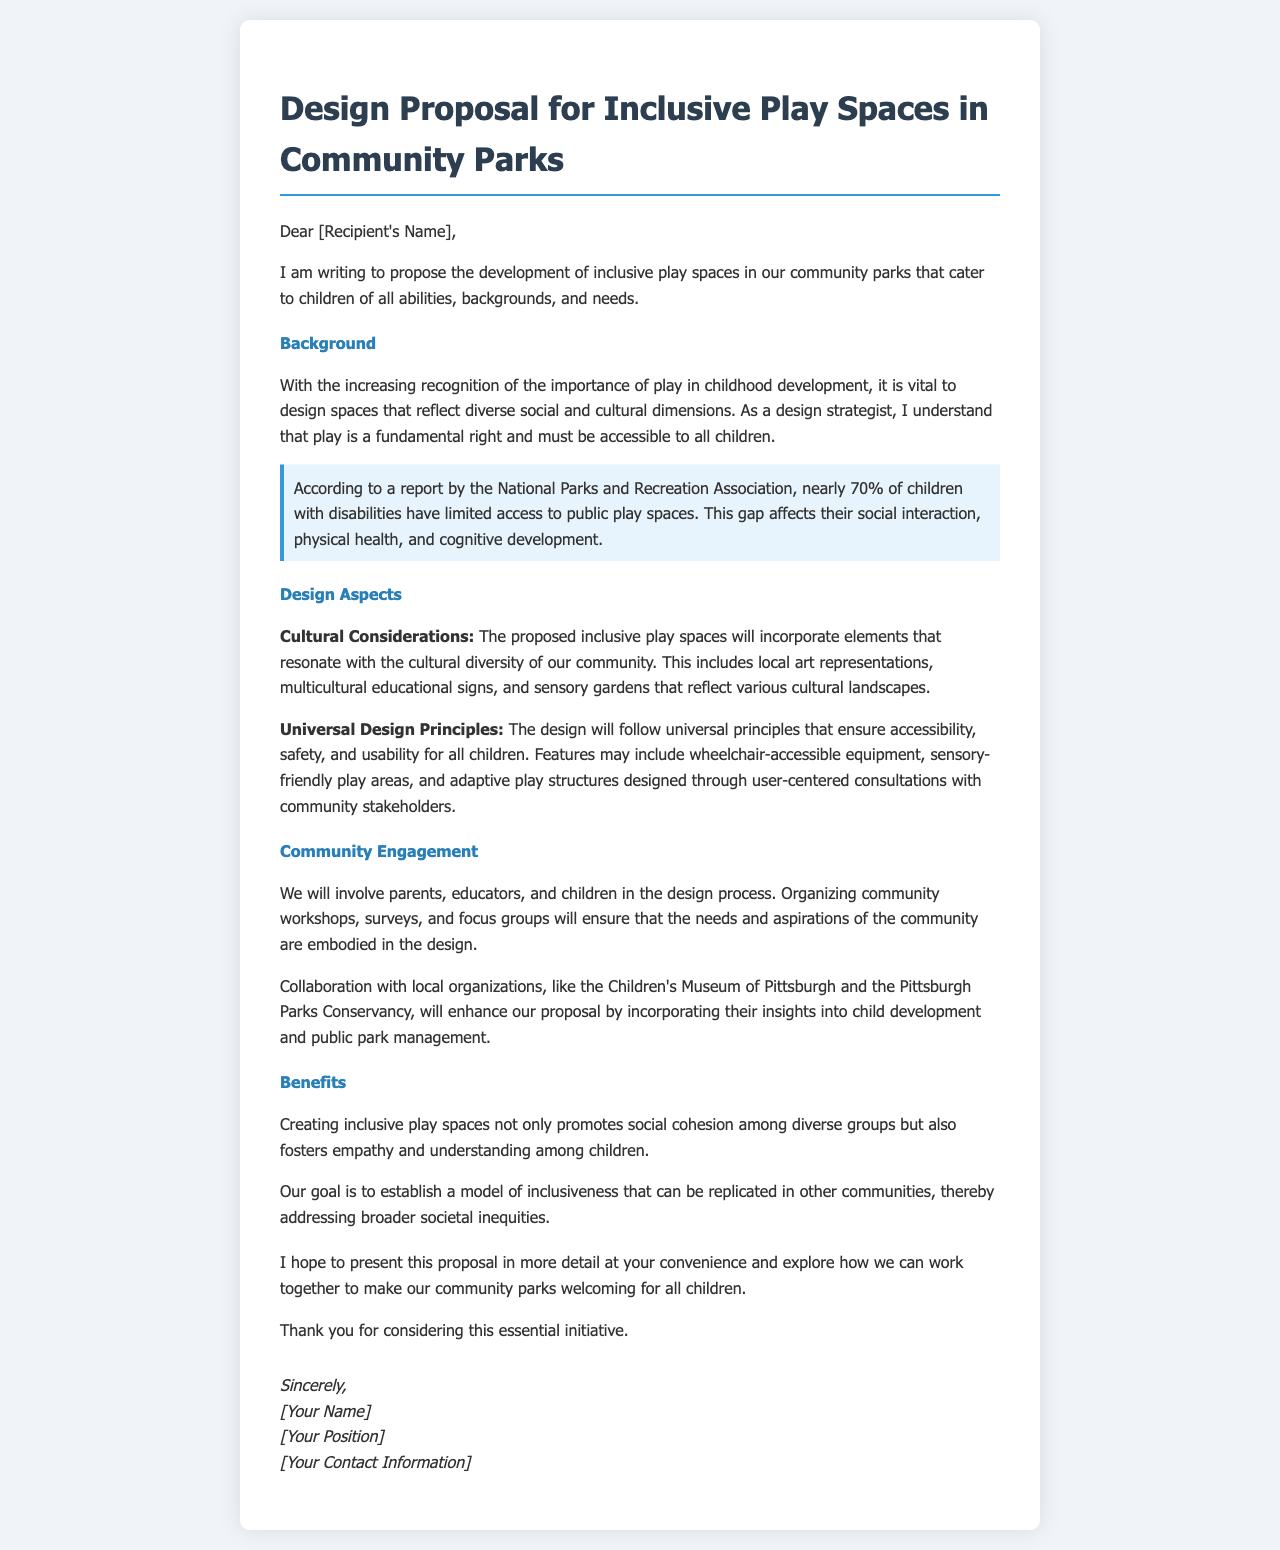what is the main proposal in the letter? The letter proposes the development of inclusive play spaces in community parks for children of all abilities, backgrounds, and needs.
Answer: inclusive play spaces how many percent of children with disabilities have limited access to public play spaces? The document states that nearly 70% of children with disabilities have limited access to public play spaces.
Answer: 70% what type of organizations will be collaborated with? The proposal mentions collaboration with local organizations like the Children's Museum of Pittsburgh and the Pittsburgh Parks Conservancy.
Answer: Children's Museum of Pittsburgh and the Pittsburgh Parks Conservancy what are the cultural aspects included in the design? The design will incorporate elements like local art representations, multicultural educational signs, and sensory gardens reflecting various cultural landscapes.
Answer: local art representations, multicultural educational signs, sensory gardens who will be involved in the design process? Parents, educators, and children will be involved in the design process through workshops, surveys, and focus groups.
Answer: Parents, educators, and children what principle will the design follow? The design will follow universal principles that ensure accessibility, safety, and usability for all children.
Answer: universal principles what is one benefit of creating inclusive play spaces? One benefit mentioned is that it promotes social cohesion among diverse groups.
Answer: social cohesion what is the call to action in the letter? The call to action is to present the proposal in detail and explore collaboration to make community parks welcoming for all children.
Answer: explore collaboration to make community parks welcoming for all children 